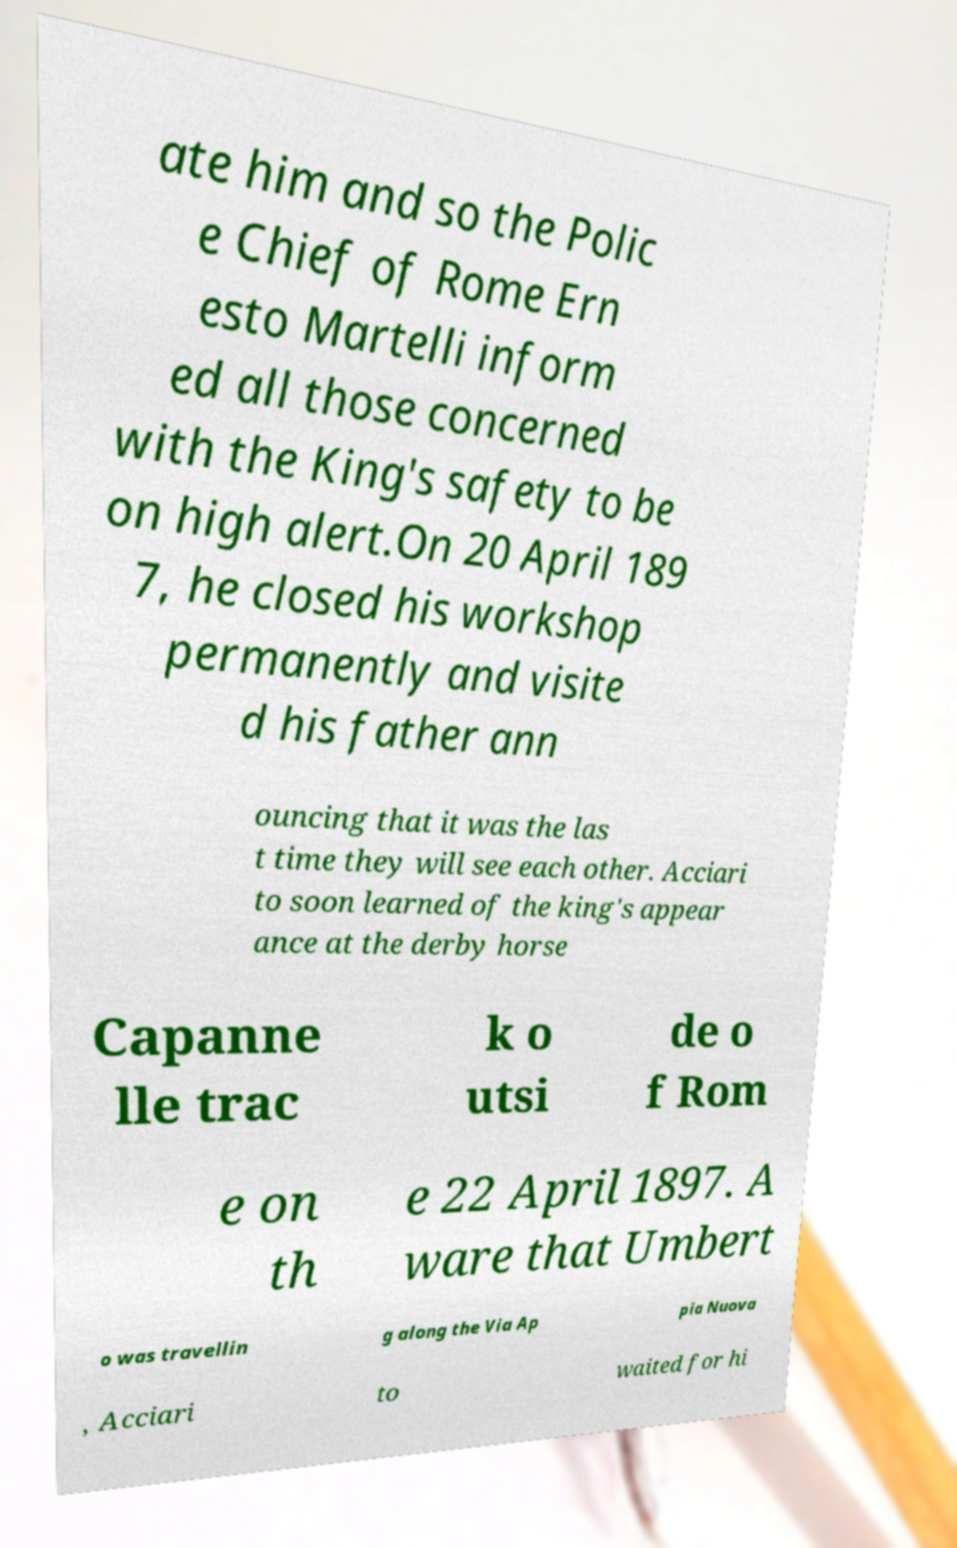Please read and relay the text visible in this image. What does it say? ate him and so the Polic e Chief of Rome Ern esto Martelli inform ed all those concerned with the King's safety to be on high alert.On 20 April 189 7, he closed his workshop permanently and visite d his father ann ouncing that it was the las t time they will see each other. Acciari to soon learned of the king's appear ance at the derby horse Capanne lle trac k o utsi de o f Rom e on th e 22 April 1897. A ware that Umbert o was travellin g along the Via Ap pia Nuova , Acciari to waited for hi 